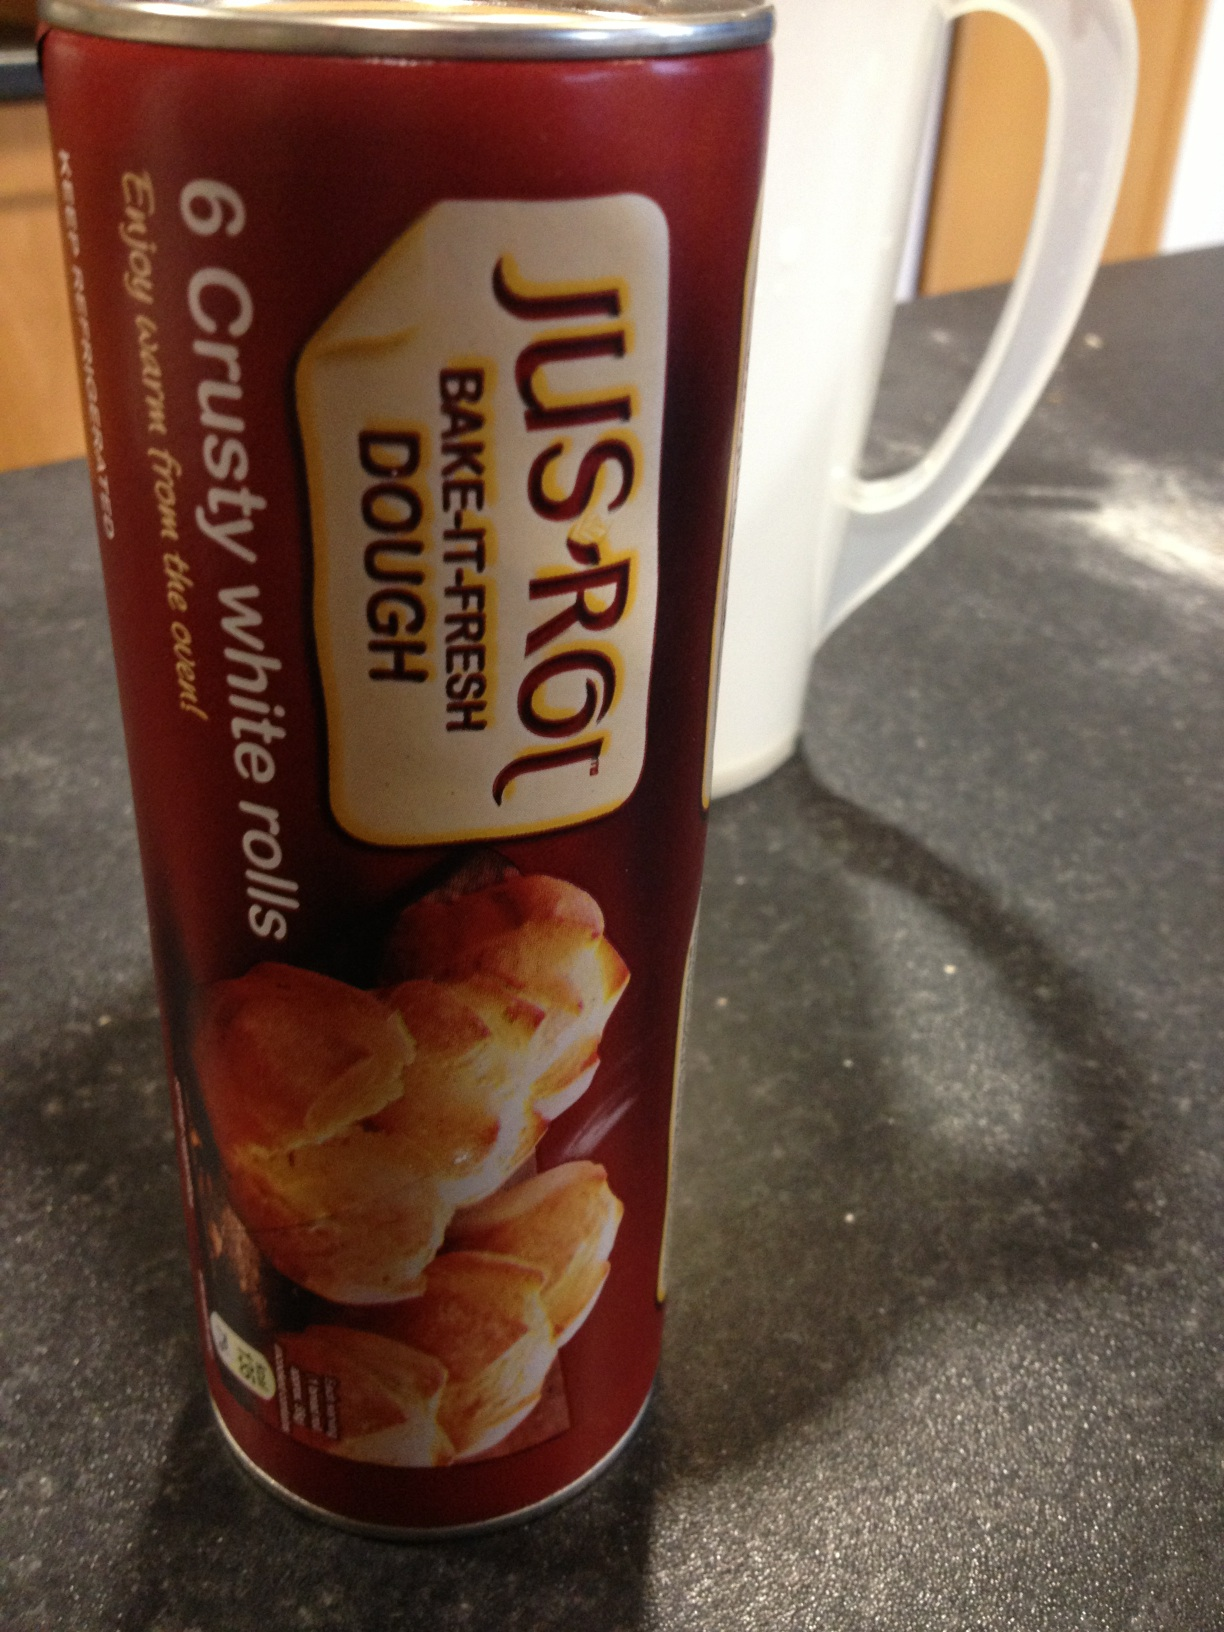What instructions would you give to someone new to using this dough? Using Jus-Rol dough is simple and perfect for beginners. Here are the steps:
1. Preheat your oven to the temperature specified on the package.
2. Remove the dough from the canister and cut it into the desired shapes for rolls.
3. Place the shaped dough pieces on a baking sheet lined with parchment paper.
4. Optionally, you can brush the tops with melted butter or an egg wash for a golden glaze.
5. Bake according to the time indicated on the package, usually until the rolls are golden brown.
6. Let them cool slightly before serving warm. Enjoy your freshly baked rolls! 